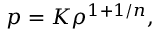<formula> <loc_0><loc_0><loc_500><loc_500>p = K \rho ^ { 1 + 1 / n } ,</formula> 